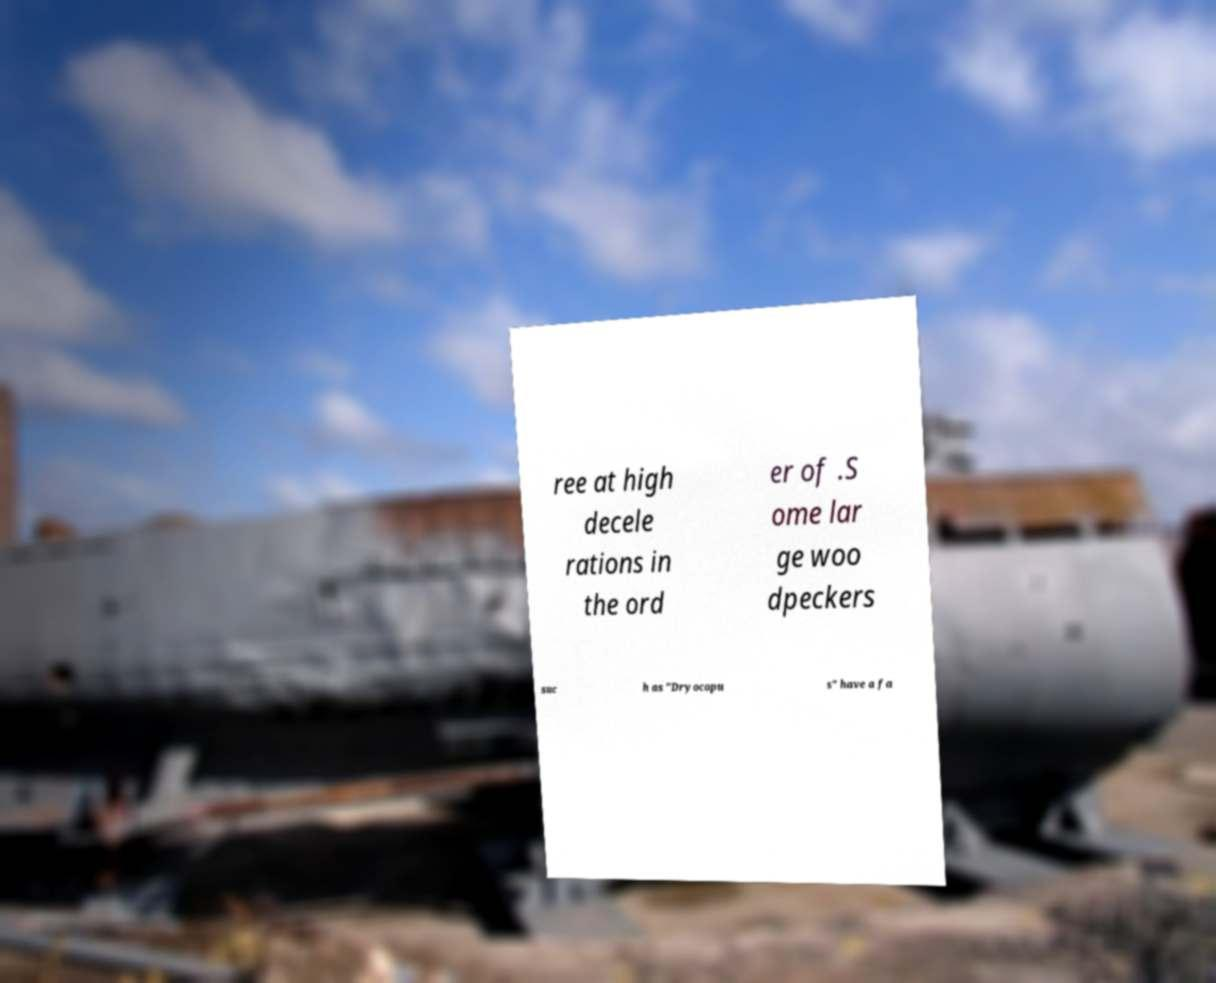I need the written content from this picture converted into text. Can you do that? ree at high decele rations in the ord er of .S ome lar ge woo dpeckers suc h as "Dryocopu s" have a fa 